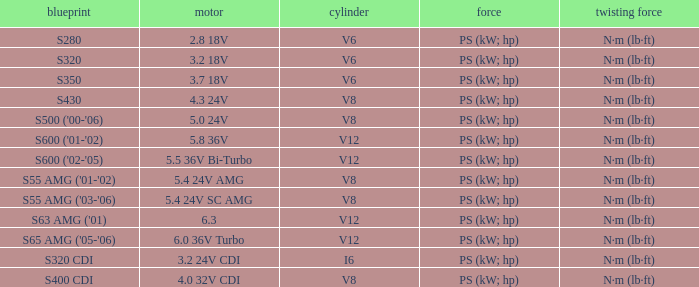Which Engine has a Model of s320 cdi? 3.2 24V CDI. 